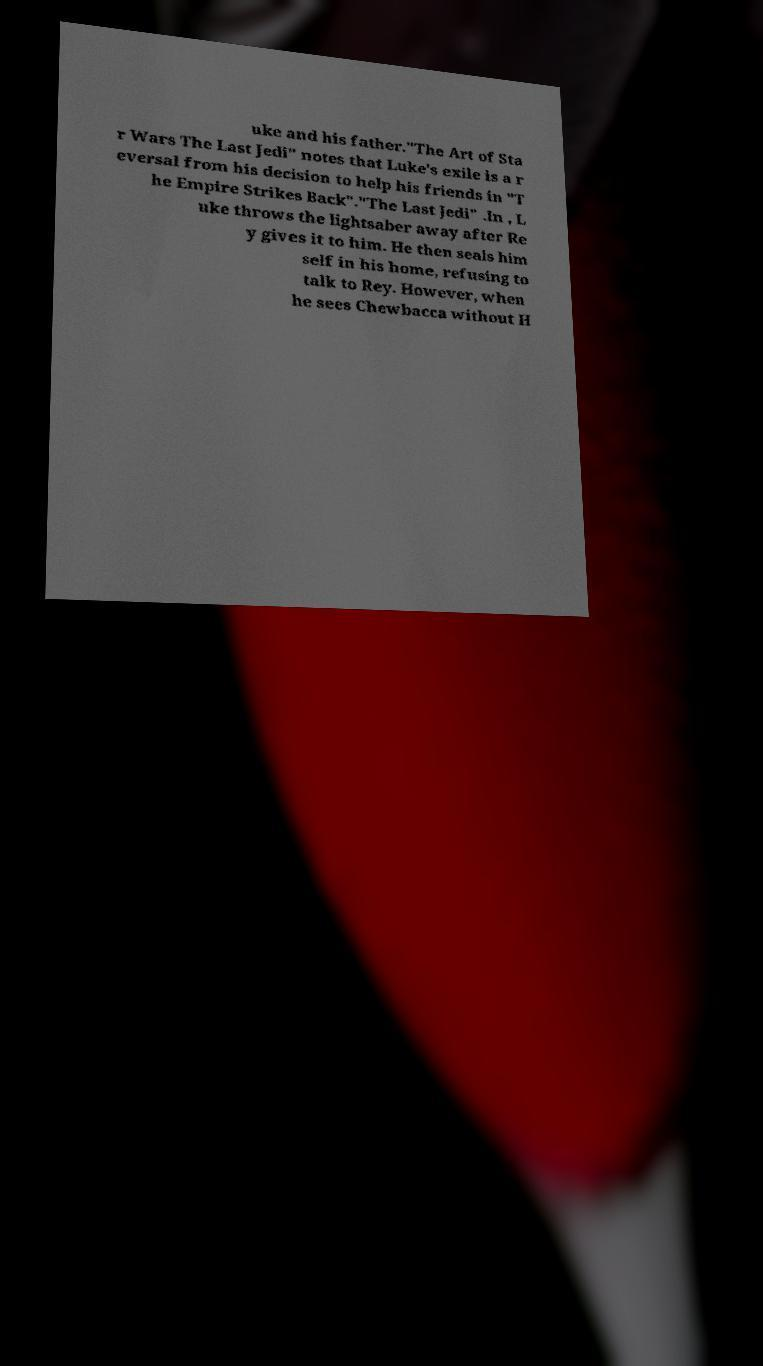Could you assist in decoding the text presented in this image and type it out clearly? uke and his father."The Art of Sta r Wars The Last Jedi" notes that Luke's exile is a r eversal from his decision to help his friends in "T he Empire Strikes Back"."The Last Jedi" .In , L uke throws the lightsaber away after Re y gives it to him. He then seals him self in his home, refusing to talk to Rey. However, when he sees Chewbacca without H 